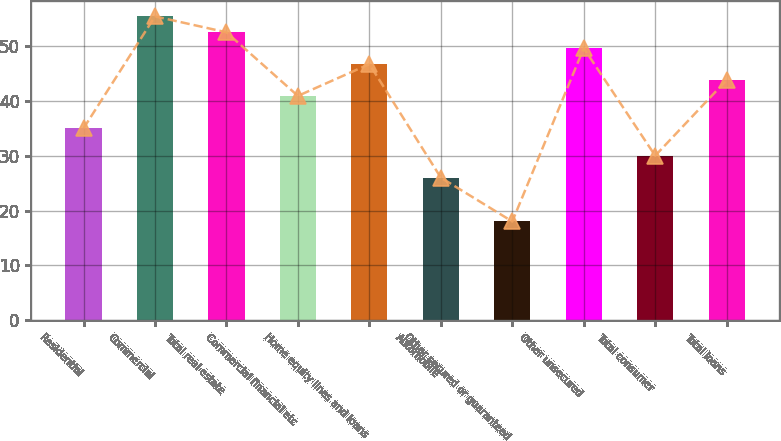Convert chart to OTSL. <chart><loc_0><loc_0><loc_500><loc_500><bar_chart><fcel>Residential<fcel>Commercial<fcel>Total real estate<fcel>Commercial financial etc<fcel>Home equity lines and loans<fcel>Automobile<fcel>Other secured or guaranteed<fcel>Other unsecured<fcel>Total consumer<fcel>Total loans<nl><fcel>35<fcel>55.4<fcel>52.5<fcel>40.9<fcel>46.7<fcel>26<fcel>18<fcel>49.6<fcel>30<fcel>43.8<nl></chart> 